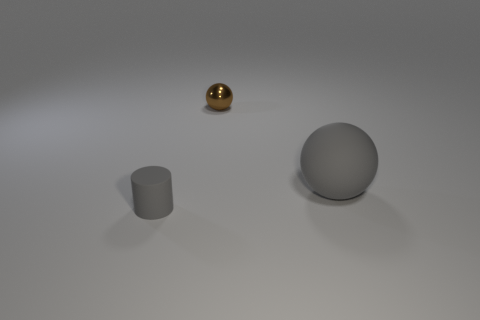There is a object that is the same color as the small cylinder; what size is it?
Give a very brief answer. Large. There is a tiny gray object; are there any tiny things behind it?
Your answer should be compact. Yes. There is a gray rubber object that is to the left of the large gray matte object; how many matte spheres are in front of it?
Your answer should be very brief. 0. Do the metallic object and the ball in front of the small shiny thing have the same size?
Provide a succinct answer. No. Is there a metallic object that has the same color as the big sphere?
Ensure brevity in your answer.  No. The other object that is the same material as the big gray object is what size?
Your response must be concise. Small. Is the small brown thing made of the same material as the big gray thing?
Your answer should be compact. No. There is a sphere that is right of the tiny object right of the gray rubber object that is in front of the gray sphere; what color is it?
Your answer should be very brief. Gray. There is a large object; what shape is it?
Give a very brief answer. Sphere. Do the small cylinder and the ball in front of the brown object have the same color?
Make the answer very short. Yes. 